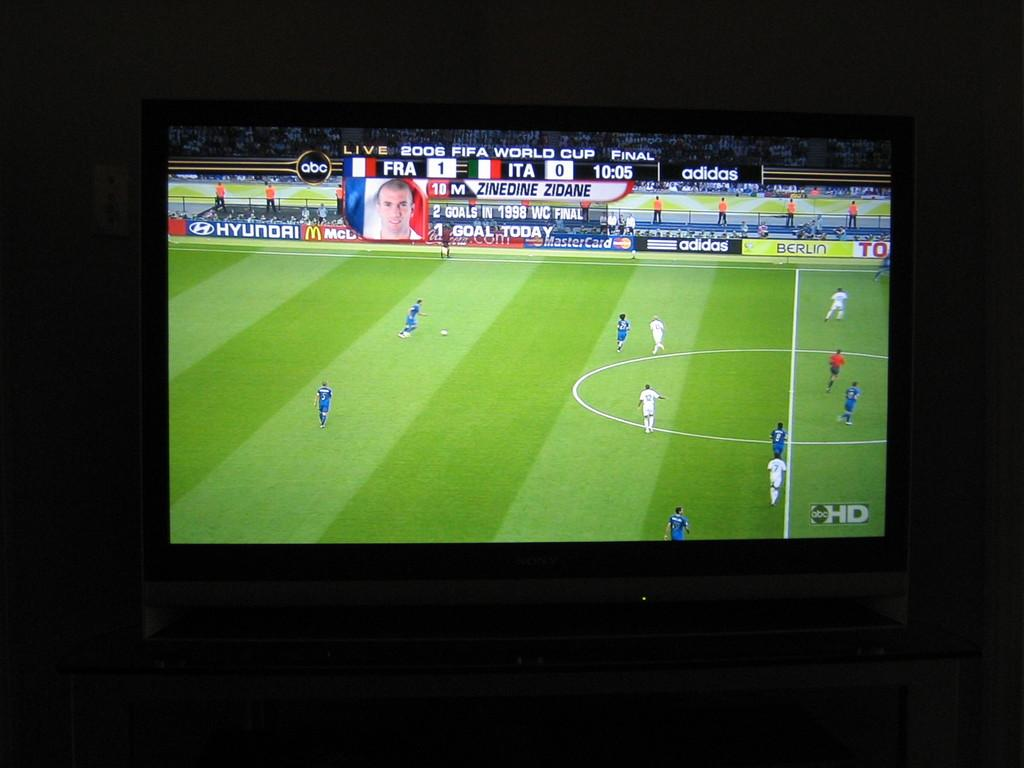<image>
Create a compact narrative representing the image presented. A tv showing a soccer game on the ABC HD channel/ 